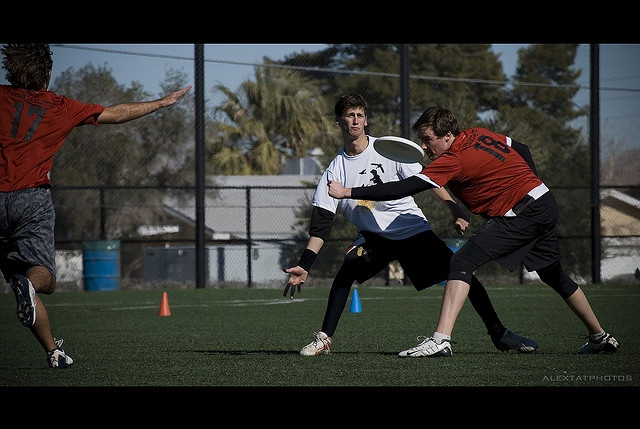Describe the objects in this image and their specific colors. I can see people in black, lightgray, gray, and navy tones, people in black, maroon, brown, and darkgray tones, people in black, maroon, and gray tones, and frisbee in black, lightgray, and purple tones in this image. 